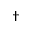Convert formula to latex. <formula><loc_0><loc_0><loc_500><loc_500>^ { \dag }</formula> 